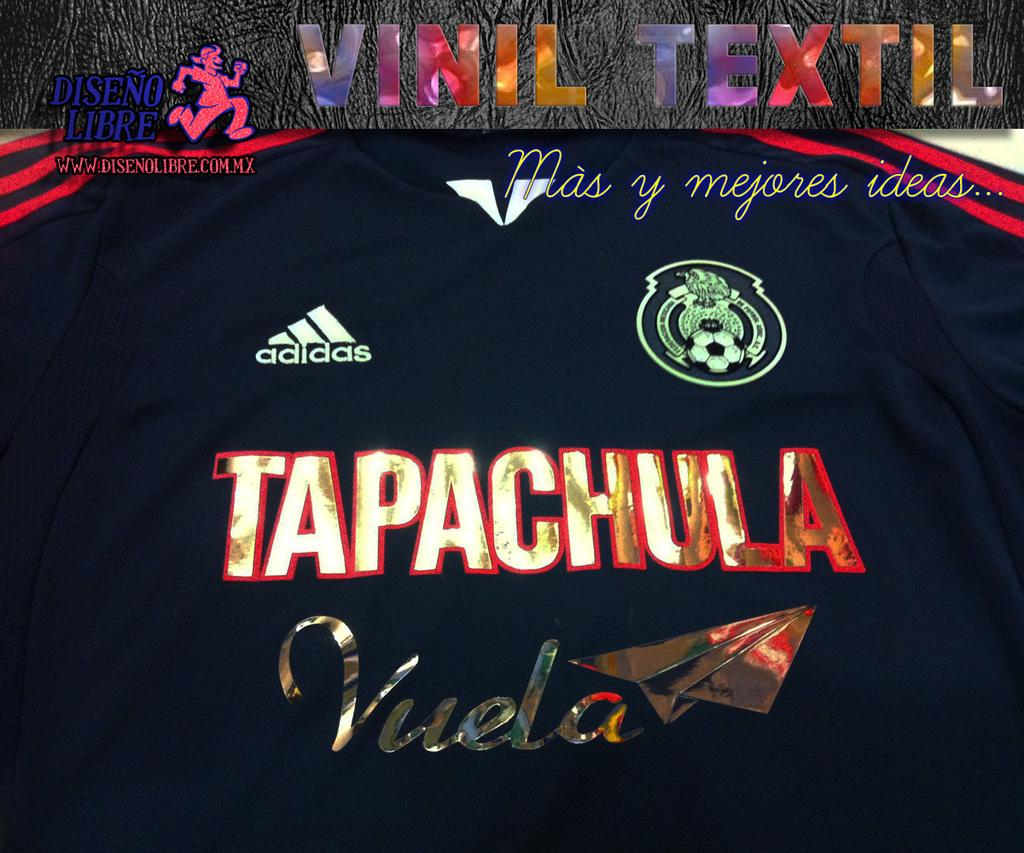<image>
Describe the image concisely. The adidas top shown has the word tapachula on it. 